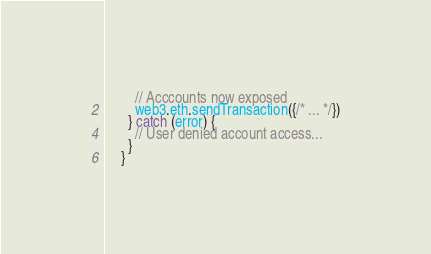<code> <loc_0><loc_0><loc_500><loc_500><_JavaScript_>
        // Acccounts now exposed
        web3.eth.sendTransaction({/* ... */})
      } catch (error) {
        // User denied account access...
      }
    }</code> 